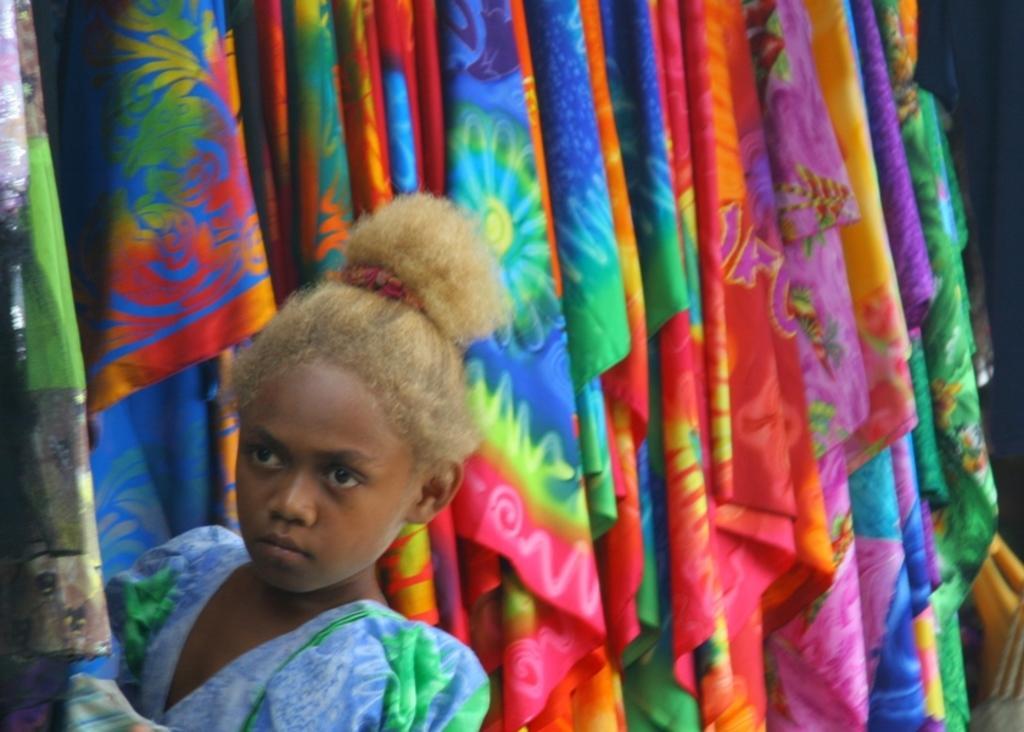Could you give a brief overview of what you see in this image? In this picture I can observe a girl wearing blue color dress on the left side. In the background I can observe different colors of clothes. I can observe blue, red, green and pink color clothes in this picture. 